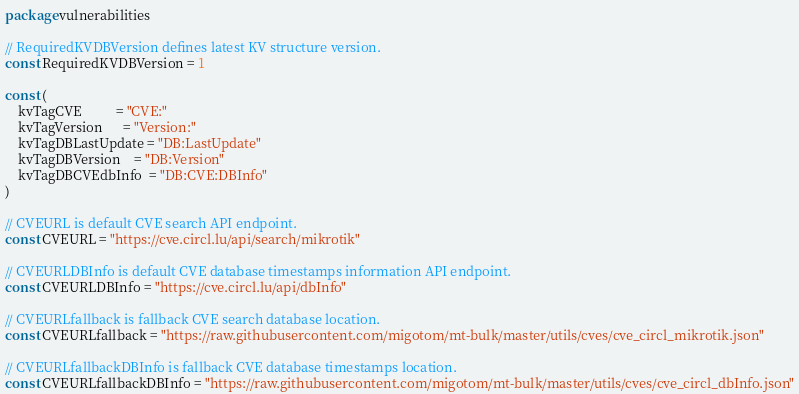<code> <loc_0><loc_0><loc_500><loc_500><_Go_>package vulnerabilities

// RequiredKVDBVersion defines latest KV structure version.
const RequiredKVDBVersion = 1

const (
	kvTagCVE          = "CVE:"
	kvTagVersion      = "Version:"
	kvTagDBLastUpdate = "DB:LastUpdate"
	kvTagDBVersion    = "DB:Version"
	kvTagDBCVEdbInfo  = "DB:CVE:DBInfo"
)

// CVEURL is default CVE search API endpoint.
const CVEURL = "https://cve.circl.lu/api/search/mikrotik"

// CVEURLDBInfo is default CVE database timestamps information API endpoint.
const CVEURLDBInfo = "https://cve.circl.lu/api/dbInfo"

// CVEURLfallback is fallback CVE search database location.
const CVEURLfallback = "https://raw.githubusercontent.com/migotom/mt-bulk/master/utils/cves/cve_circl_mikrotik.json"

// CVEURLfallbackDBInfo is fallback CVE database timestamps location.
const CVEURLfallbackDBInfo = "https://raw.githubusercontent.com/migotom/mt-bulk/master/utils/cves/cve_circl_dbInfo.json"
</code> 